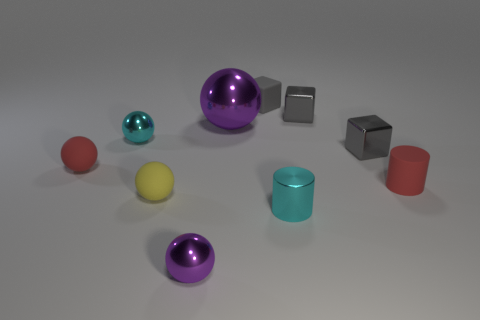How many purple balls must be subtracted to get 1 purple balls? 1 Subtract all red spheres. How many spheres are left? 4 Subtract 2 balls. How many balls are left? 3 Subtract all big purple balls. How many balls are left? 4 Subtract all green spheres. Subtract all brown cylinders. How many spheres are left? 5 Subtract all blocks. How many objects are left? 7 Add 4 red cylinders. How many red cylinders are left? 5 Add 9 tiny purple metallic balls. How many tiny purple metallic balls exist? 10 Subtract 1 cyan spheres. How many objects are left? 9 Subtract all tiny yellow spheres. Subtract all tiny yellow rubber things. How many objects are left? 8 